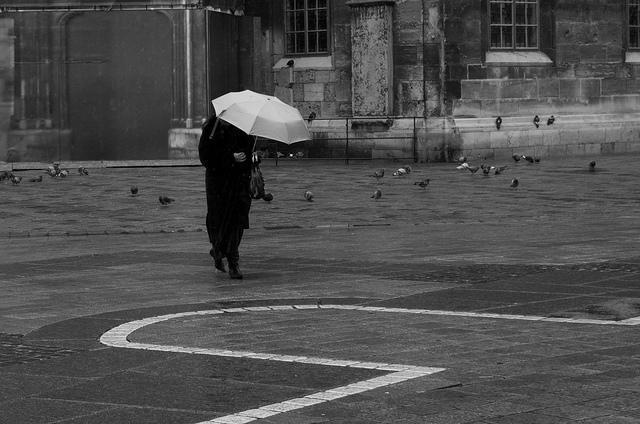What is the person hiding behind?
Select the correct answer and articulate reasoning with the following format: 'Answer: answer
Rationale: rationale.'
Options: Umbrella, car, apple, box. Answer: umbrella.
Rationale: Am umbrella is covering their face. 